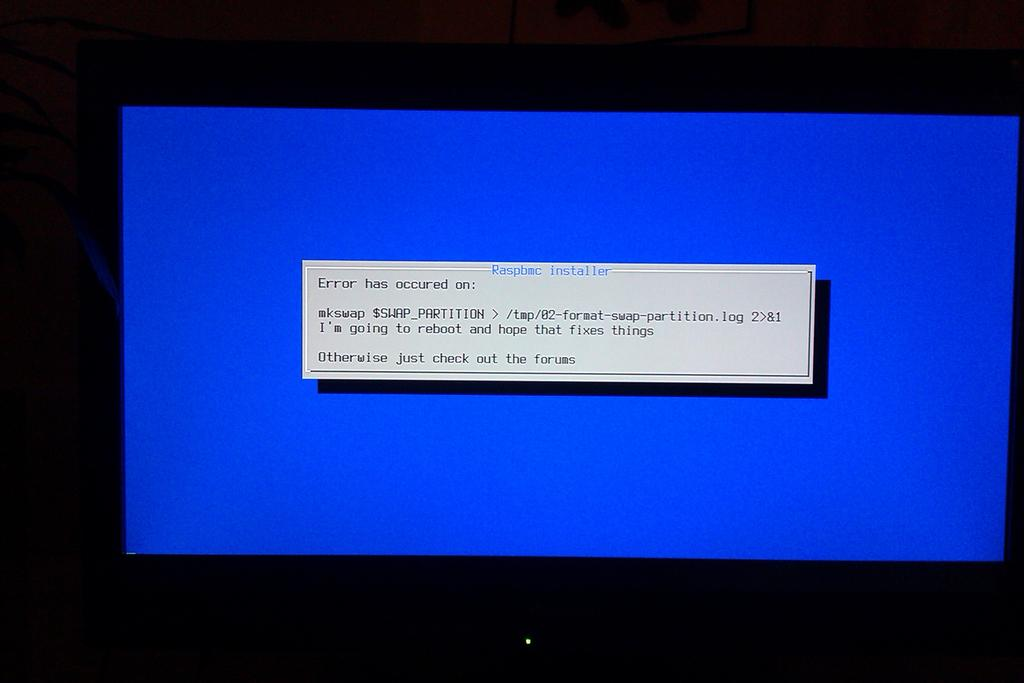<image>
Provide a brief description of the given image. A computer screen flashes the blue screen of death and gives an error message and directs people to forums. 